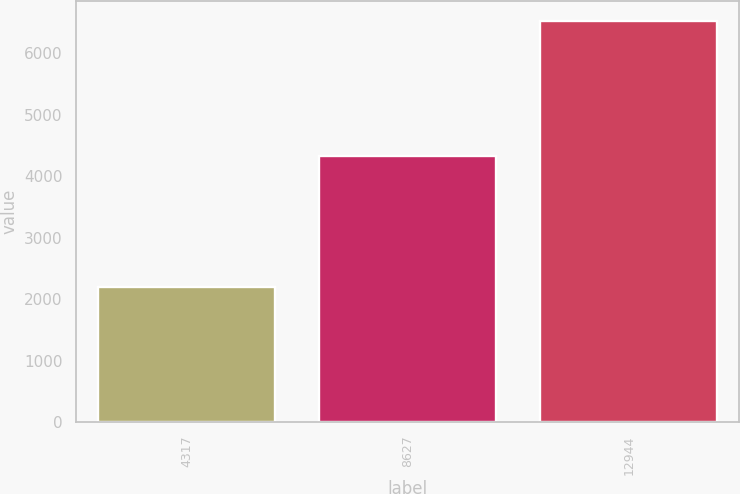Convert chart. <chart><loc_0><loc_0><loc_500><loc_500><bar_chart><fcel>4317<fcel>8627<fcel>12944<nl><fcel>2204<fcel>4325<fcel>6529<nl></chart> 